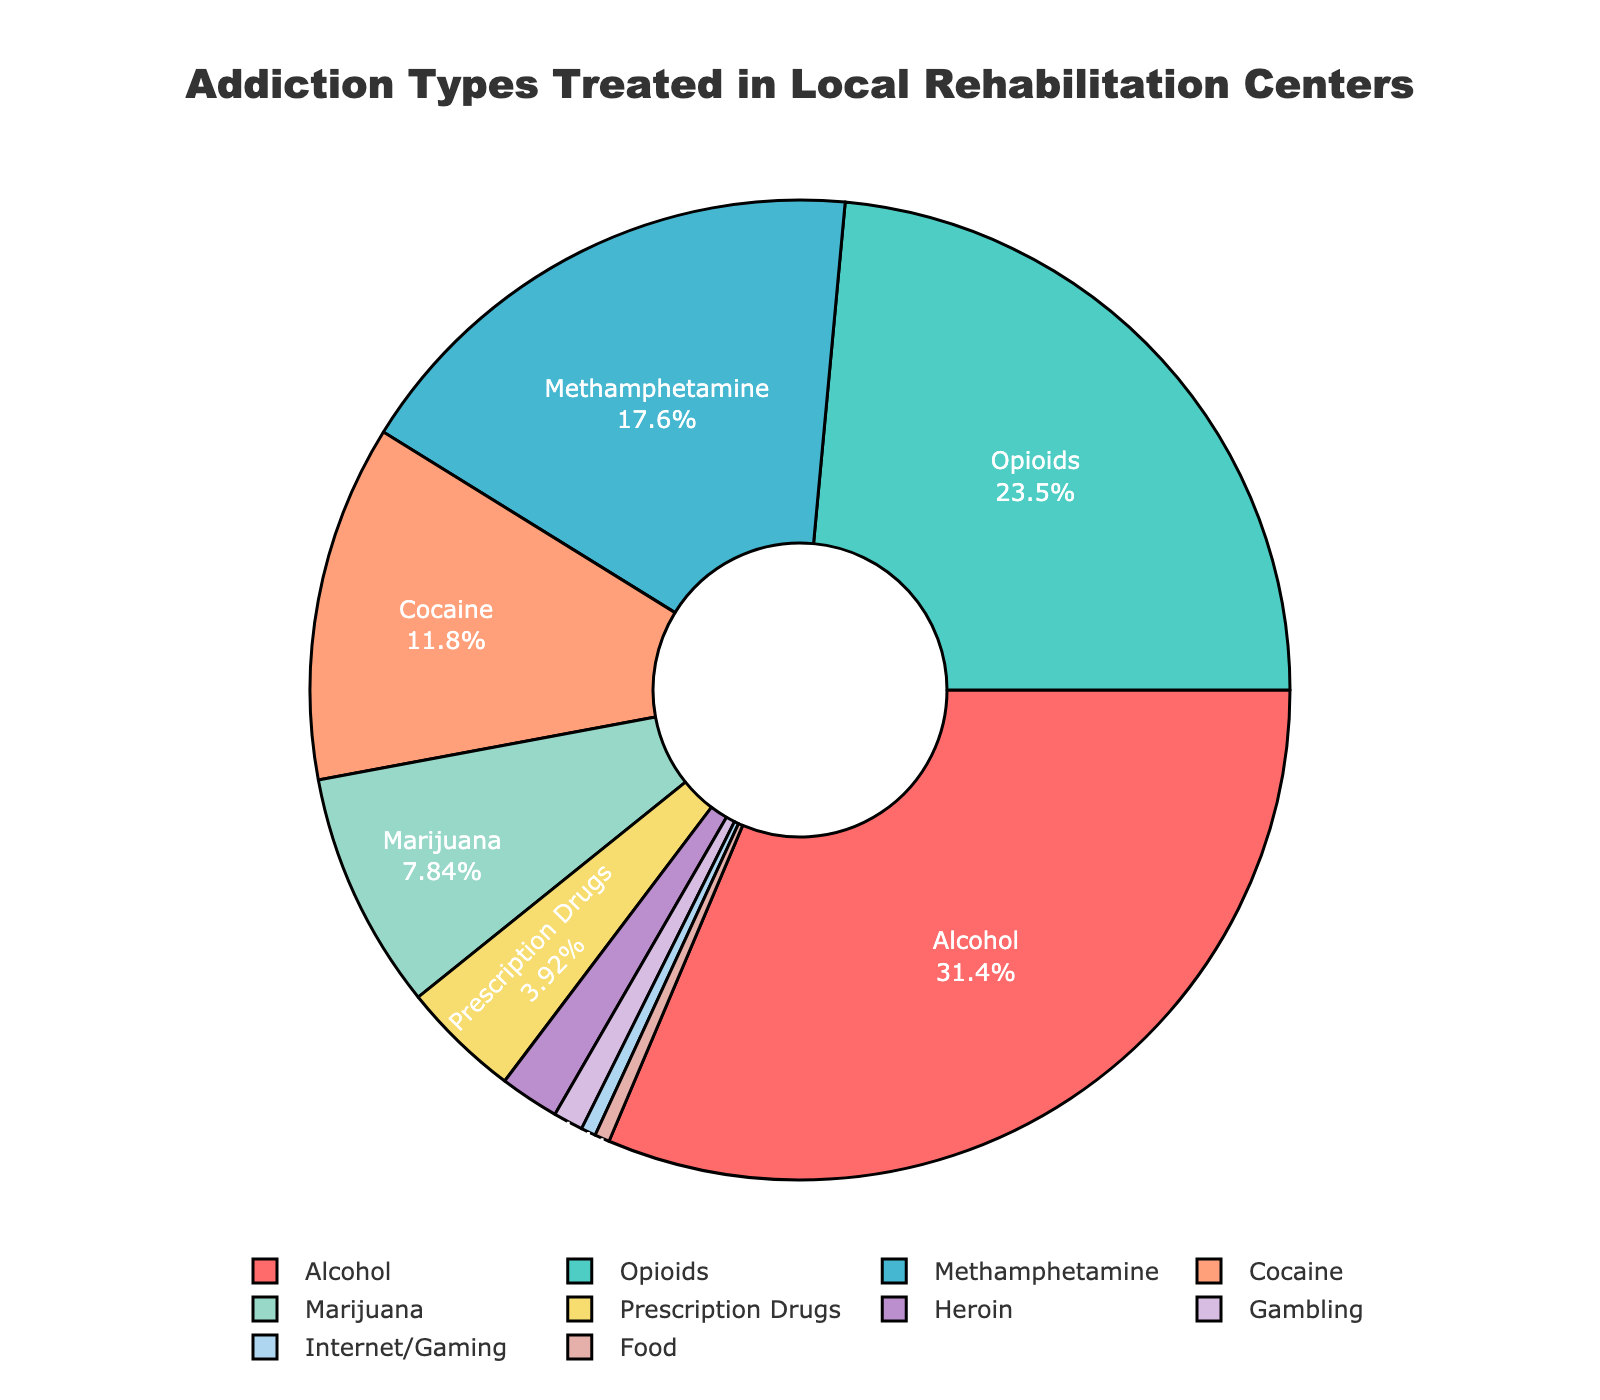What is the most common addiction type treated in local rehabilitation centers? The largest segment in the pie chart represents the most common addiction type treated. The biggest segment is labeled "Alcohol" with 32%.
Answer: Alcohol Which addiction type is the least common among those listed? The smallest segment in the pie chart represents the least common addiction type. "Internet/Gaming" and "Food" are both the smallest with 0.5%.
Answer: Internet/Gaming and Food What is the combined percentage of Opioids and Methamphetamine addictions treated? Add the percentages for Opioids (24%) and Methamphetamine (18%). 24 + 18 = 42.
Answer: 42% Is the proportion of Alcohol addiction treatment greater than all Prescription Drugs, Heroin, Gambling, Internet/Gaming, and Food combined? Sum the percentages of Prescription Drugs (4%), Heroin (2%), Gambling (1%), Internet/Gaming (0.5%), and Food (0.5%). 4 + 2 + 1 + 0.5 + 0.5 = 8%. The Alcohol addiction percentage is 32%, which is greater.
Answer: Yes What entity represents the second largest portion of addiction types treated? The second largest segment in the pie chart is labeled "Opioids" with 24%.
Answer: Opioids How much larger is the percentage of Marijuana addiction treated compared to Prescription Drugs? Subtract Prescription Drugs percentage (4%) from Marijuana percentage (8%). 8 - 4 = 4.
Answer: 4% What is the total percentage of addictions treated that are non-Alcohol related? Subtract the percentage of Alcohol addiction (32%) from 100%. 100 - 32 = 68.
Answer: 68% What colors represent the addiction types of Alcohol and Cocaine respectively? The segment representing Alcohol is colored red, and the segment for Cocaine is colored light orange.
Answer: Red for Alcohol, Light Orange for Cocaine Compared to Cocaine, is the percentage of Methamphetamine addiction higher or lower? By how much? Methamphetamine has 18% and Cocaine has 12%. Subtract Cocaine percentage from Methamphetamine. 18 - 12 = 6.
Answer: Higher by 6% What are the percentages for the categories labeled as Heroin and Gambling? The pie chart segment for Heroin shows 2% and for Gambling shows 1%.
Answer: Heroin: 2%, Gambling: 1% 